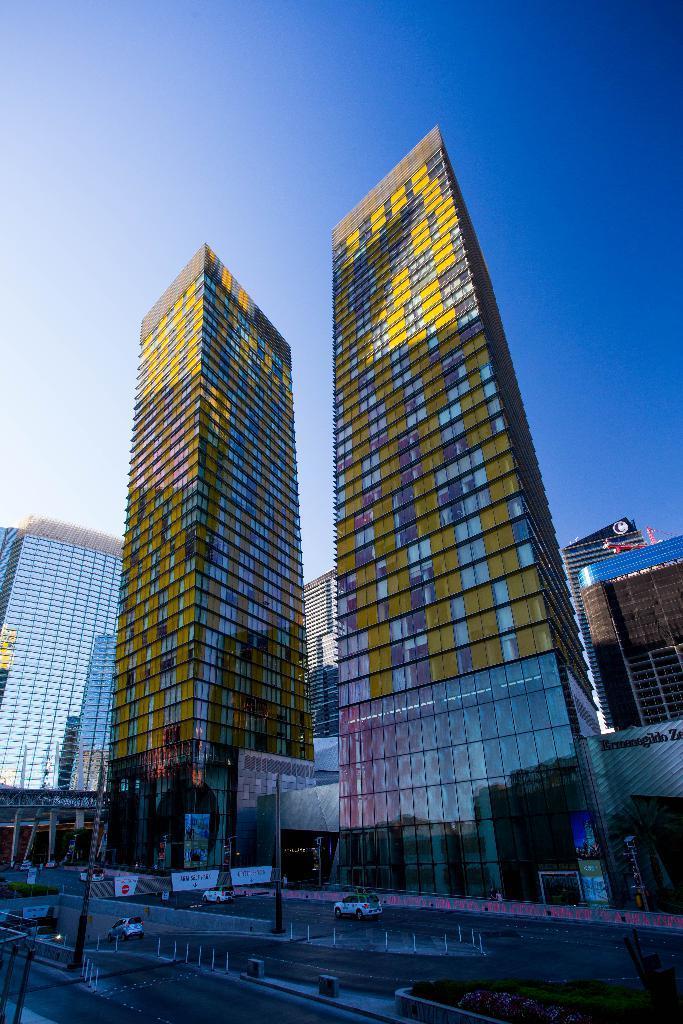Please provide a concise description of this image. In this image we can see multiple buildings. Bottom of the image road is there, on road cars are moving. The sky is in blue color. 